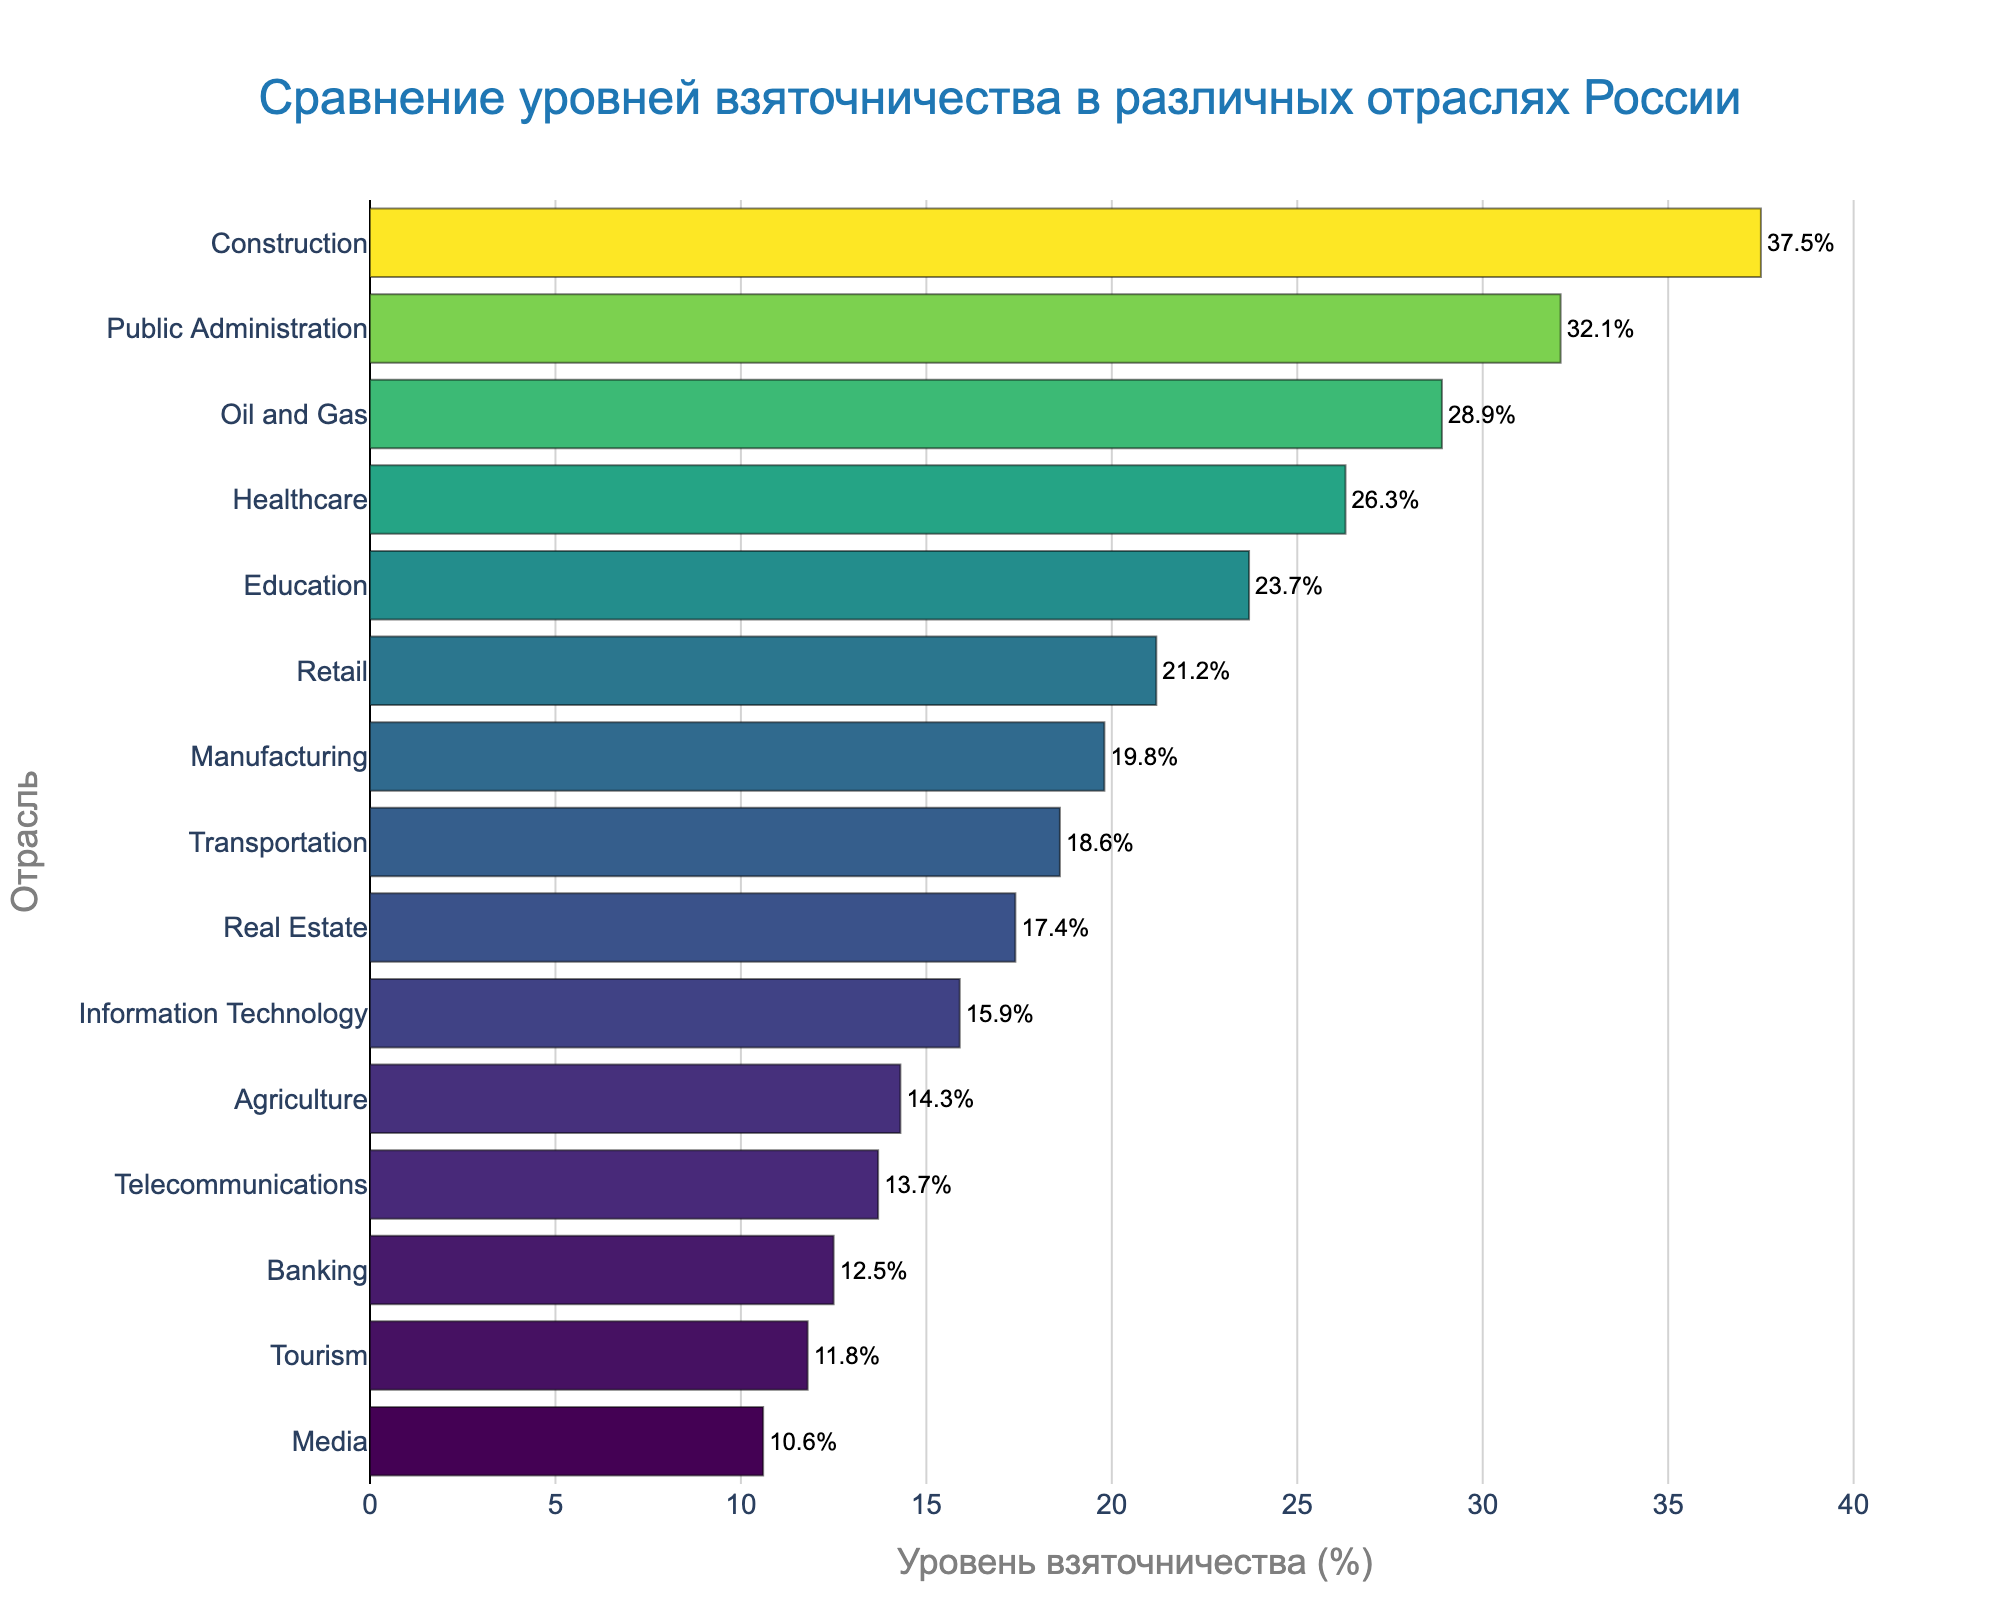Which industry has the highest bribery rate? Observing the bar chart, the Construction industry has the highest bribery rate as indicated by the longest bar.
Answer: Construction What is the difference in bribery rates between the Construction and Banking industries? The bribery rate for Construction is 37.5%, and for Banking, it is 12.5%. Compute the difference by subtracting: 37.5% - 12.5% = 25%.
Answer: 25% How does the bribery rate in Healthcare compare to that in Retail? The bribery rate in Healthcare is 26.3% while in Retail it is 21.2%. Since 26.3% is greater than 21.2%, the Healthcare industry has a higher bribery rate than Retail.
Answer: Healthcare has a higher rate Which industry has a lower bribery rate: Agriculture or Telecommunications? By looking at the bars, Agriculture has a bribery rate of 14.3% and Telecommunications has 13.7%. Therefore, Telecommunications has a lower bribery rate.
Answer: Telecommunications What is the sum of the bribery rates for Education, Real Estate, and Oil and Gas? The bribery rates are 23.7% for Education, 17.4% for Real Estate, and 28.9% for Oil and Gas. Summing these values: 23.7% + 17.4% + 28.9% = 70%.
Answer: 70% Which industry has the closest bribery rate to 20%? Observing the lengths of the bars, the closest rate to 20% is for Retail, which has a bribery rate of 21.2%.
Answer: Retail How does the bribery rate in Media compare to that in Tourism? The bribery rate in Media is 10.6% and in Tourism, it is 11.8%. Since 10.6% is less than 11.8%, Media has a lower bribery rate.
Answer: Media has a lower rate What is the average bribery rate of the top three industries with the highest rates? The top three industries are Construction (37.5%), Public Administration (32.1%), and Oil and Gas (28.9%). Calculate the average: (37.5% + 32.1% + 28.9%) / 3 = 32.83%.
Answer: 32.83% Which industry’s bar has the darkest color and what does this indicate about its bribery rate? The bar for Construction has the darkest color, indicating it has the highest bribery rate.
Answer: Construction 